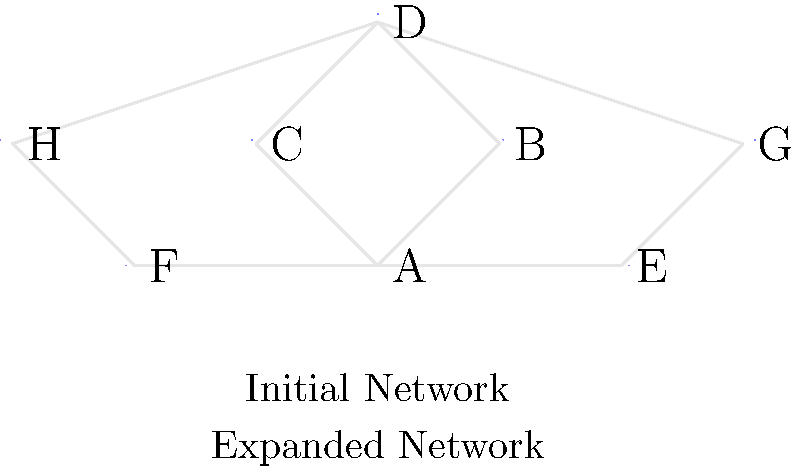In the network diagram above, which represents the growth of social connections in a senior community, how many new connections (edges) were added to expand the initial network? To determine the number of new connections added to expand the initial network, we need to follow these steps:

1. Identify the initial network:
   The initial network consists of nodes A, B, C, D, E, and F.

2. Count the connections in the initial network:
   A-B, A-C, B-D, C-D, A-E, A-F
   There are 6 connections in the initial network.

3. Identify the expanded network:
   The expanded network includes two new nodes: G and H.

4. Count the new connections in the expanded network:
   E-G: Connection between existing node E and new node G
   F-H: Connection between existing node F and new node H
   G-D: Connection between new node G and existing node D
   H-D: Connection between new node H and existing node D

5. Calculate the total number of new connections:
   There are 4 new connections added to expand the initial network.
Answer: 4 